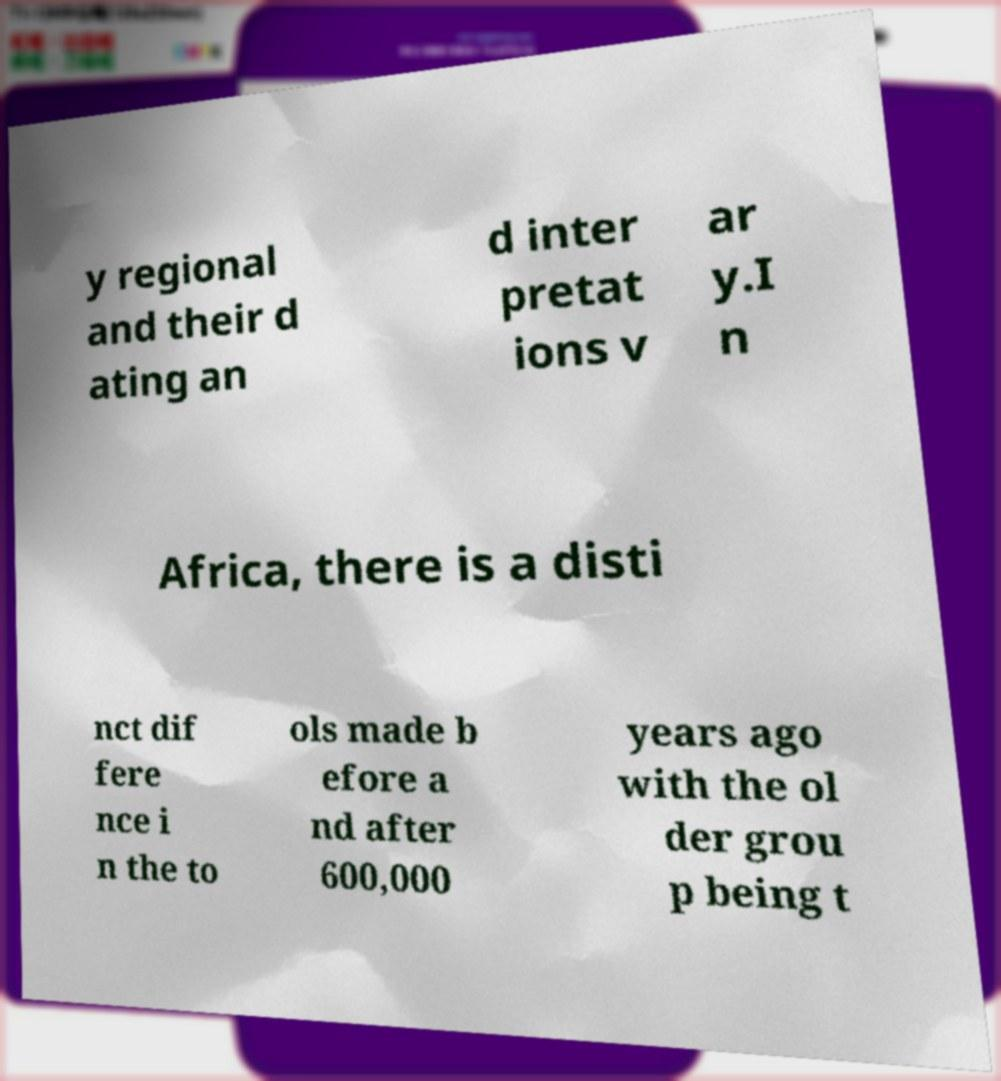Could you extract and type out the text from this image? y regional and their d ating an d inter pretat ions v ar y.I n Africa, there is a disti nct dif fere nce i n the to ols made b efore a nd after 600,000 years ago with the ol der grou p being t 